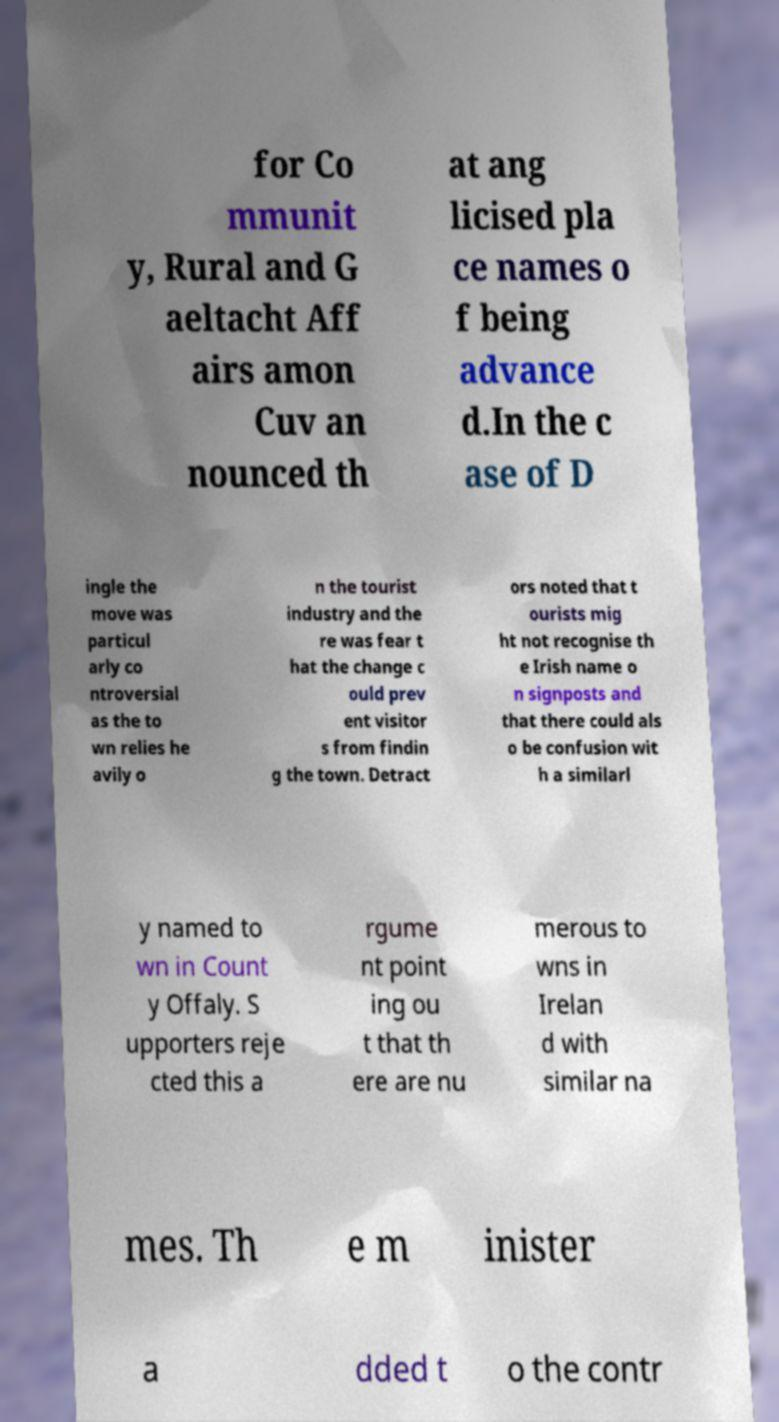Please identify and transcribe the text found in this image. for Co mmunit y, Rural and G aeltacht Aff airs amon Cuv an nounced th at ang licised pla ce names o f being advance d.In the c ase of D ingle the move was particul arly co ntroversial as the to wn relies he avily o n the tourist industry and the re was fear t hat the change c ould prev ent visitor s from findin g the town. Detract ors noted that t ourists mig ht not recognise th e Irish name o n signposts and that there could als o be confusion wit h a similarl y named to wn in Count y Offaly. S upporters reje cted this a rgume nt point ing ou t that th ere are nu merous to wns in Irelan d with similar na mes. Th e m inister a dded t o the contr 